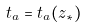Convert formula to latex. <formula><loc_0><loc_0><loc_500><loc_500>t _ { a } = t _ { a } ( z _ { * } )</formula> 